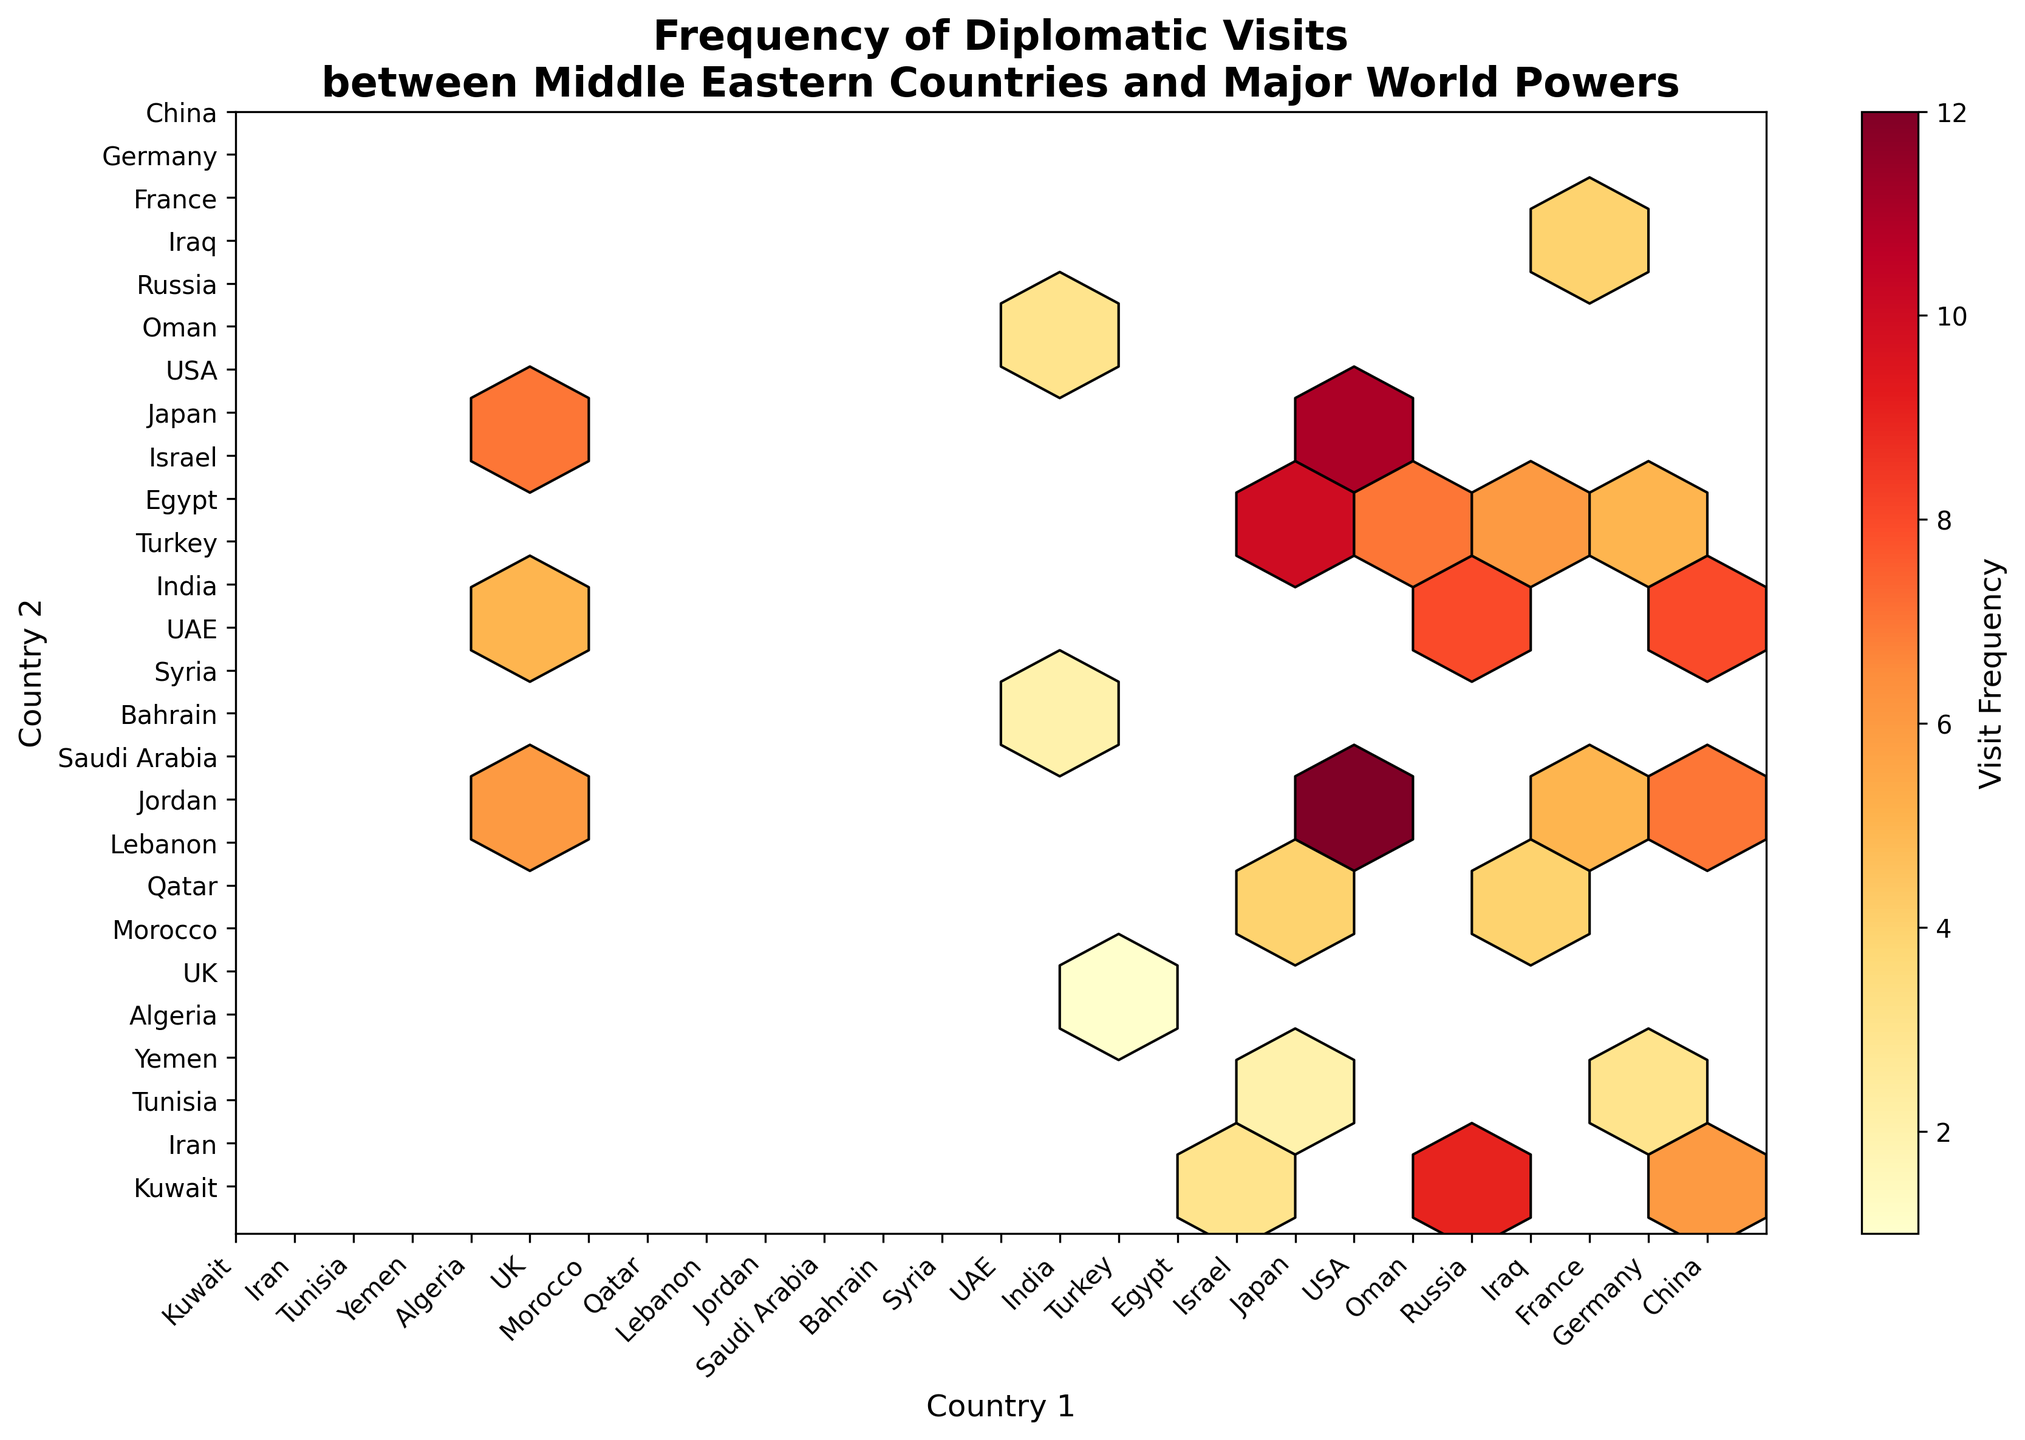Which country pair has the highest frequency of diplomatic visits? Look for the darkest hexagon on the plot, which represents the highest frequency. Locate the corresponding countries on the x and y axes.
Answer: USA and Saudi Arabia How many countries are involved in the displayed diplomatic visits? Count the unique tick labels on either the x-axis or y-axis, since both axes represent the same set of countries.
Answer: 16 What is the general color scheme used in the plot to represent visit frequency? Observe the color gradient in the plot, which shows how visit frequency is represented using different colors.
Answer: Yellow to red Which major world power has the most diplomatic visits with Middle Eastern countries? Identify the country that appears most frequently on the x-axis (country 1) with darker hexagons, indicating higher frequencies.
Answer: USA Compare the diplomatic visit frequencies between Russia-UAE and Germany-Turkey. Which pair has more visits? Find and compare the color intensities of the hexagon corresponding to Russia-UAE and Germany-Turkey. The darker/more red the hexagon, the higher the frequency.
Answer: Germany-Turkey What is the average visit frequency for France with Middle Eastern countries? Identify all hexagons involving France on either axis, sum their frequencies, and then divide by the number of hexagons.
Answer: (6+4+5)/3 = 5 Are there any pairs with a visit frequency of 10 or higher? Check the colorbar to understand the color corresponding to visit frequencies of 10 or more, then look for hexagons that match this color intensity.
Answer: USA-Saudi Arabia, USA-Israel, USA-Egypt Which pair shows a diplomatic visit frequency of exactly 6? Look for the hexagons that correspond to the color representing a frequency of 6 according to the colorbar and note the country pairs.
Answer: France-Egypt, Russia-Turkey, China-Iran, UK-Israel How does the visit frequency between India and any Middle Eastern country compare with that of Japan? Compare the color intensities of hexagons for all pairs involving India with those for Japan. Check which pair involves a darker hexagon.
Answer: India has lower visit frequencies compared to Japan 